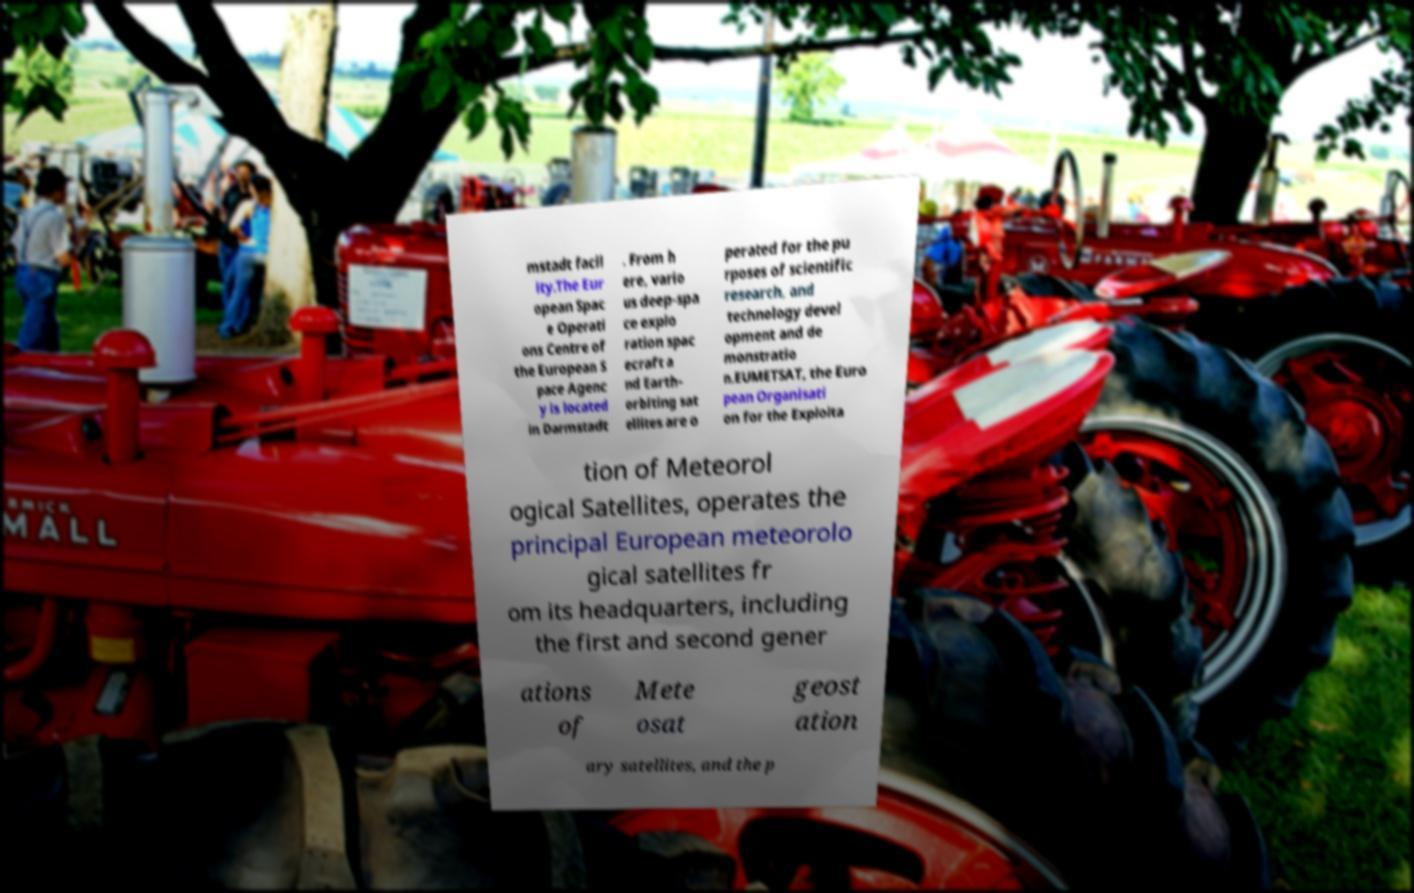For documentation purposes, I need the text within this image transcribed. Could you provide that? mstadt facil ity.The Eur opean Spac e Operati ons Centre of the European S pace Agenc y is located in Darmstadt . From h ere, vario us deep-spa ce explo ration spac ecraft a nd Earth- orbiting sat ellites are o perated for the pu rposes of scientific research, and technology devel opment and de monstratio n.EUMETSAT, the Euro pean Organisati on for the Exploita tion of Meteorol ogical Satellites, operates the principal European meteorolo gical satellites fr om its headquarters, including the first and second gener ations of Mete osat geost ation ary satellites, and the p 